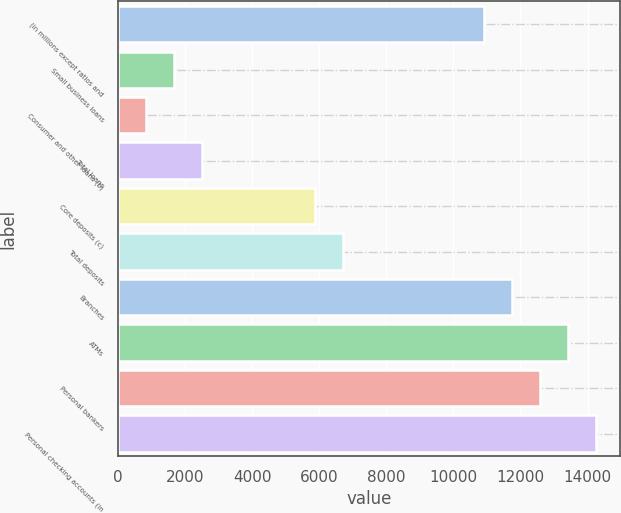Convert chart. <chart><loc_0><loc_0><loc_500><loc_500><bar_chart><fcel>(in millions except ratios and<fcel>Small business loans<fcel>Consumer and other loans (b)<fcel>Total loans<fcel>Core deposits (c)<fcel>Total deposits<fcel>Branches<fcel>ATMs<fcel>Personal bankers<fcel>Personal checking accounts (in<nl><fcel>10909.2<fcel>1679.72<fcel>840.68<fcel>2518.76<fcel>5874.92<fcel>6713.96<fcel>11748.2<fcel>13426.3<fcel>12587.2<fcel>14265.3<nl></chart> 